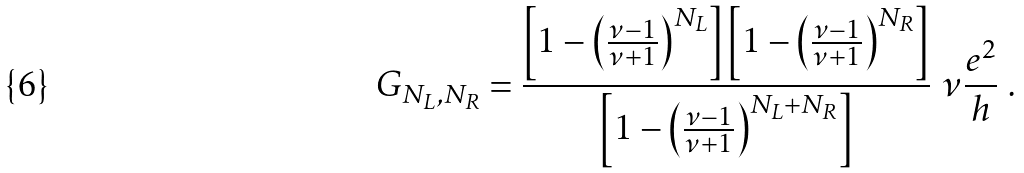<formula> <loc_0><loc_0><loc_500><loc_500>G _ { N _ { L } , N _ { R } } = \frac { \left [ 1 - \left ( \frac { \nu - 1 } { \nu + 1 } \right ) ^ { N _ { L } } \right ] \left [ 1 - \left ( \frac { \nu - 1 } { \nu + 1 } \right ) ^ { N _ { R } } \right ] } { \left [ 1 - \left ( \frac { \nu - 1 } { \nu + 1 } \right ) ^ { N _ { L } + N _ { R } } \right ] } \ \nu \frac { e ^ { 2 } } { h } \ .</formula> 